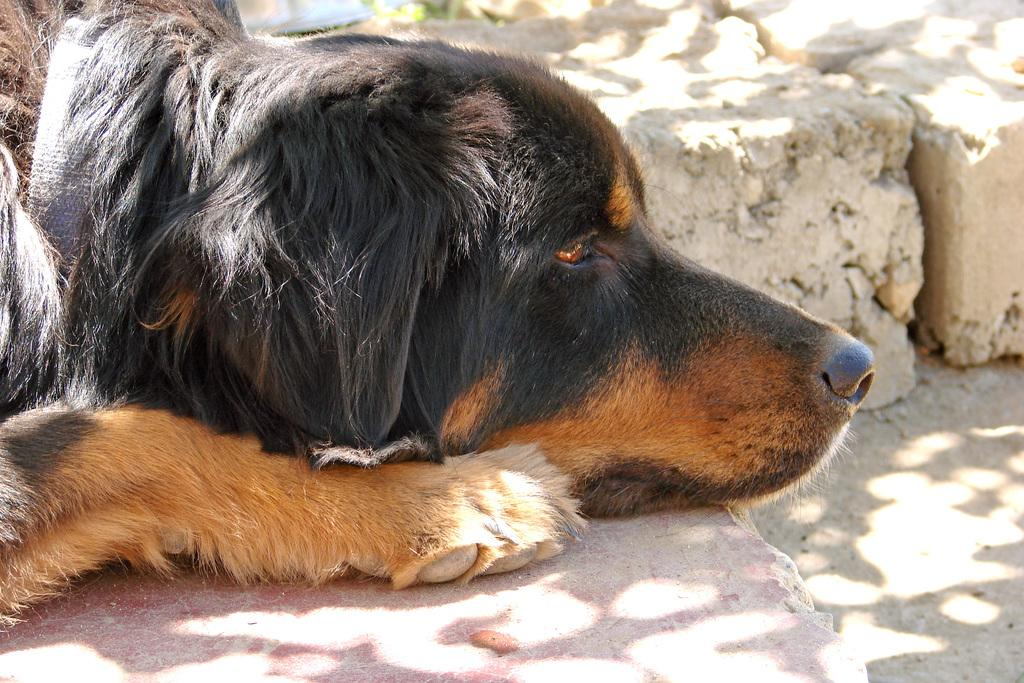What type of animal is present in the image? There is a dog in the image. In which direction is the dog facing? The dog is facing towards the right side of the image. How many sisters are depicted in the image? There are no sisters present in the image; it features a dog. What type of canvas is used for the background of the image? There is no canvas present in the image; it is a photograph or digital image. 